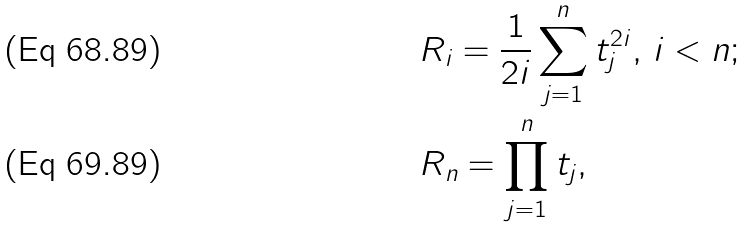Convert formula to latex. <formula><loc_0><loc_0><loc_500><loc_500>& R _ { i } = \frac { 1 } { 2 i } \sum _ { j = 1 } ^ { n } t _ { j } ^ { 2 i } , \, i < n ; \\ & R _ { n } = \prod _ { j = 1 } ^ { n } t _ { j } ,</formula> 